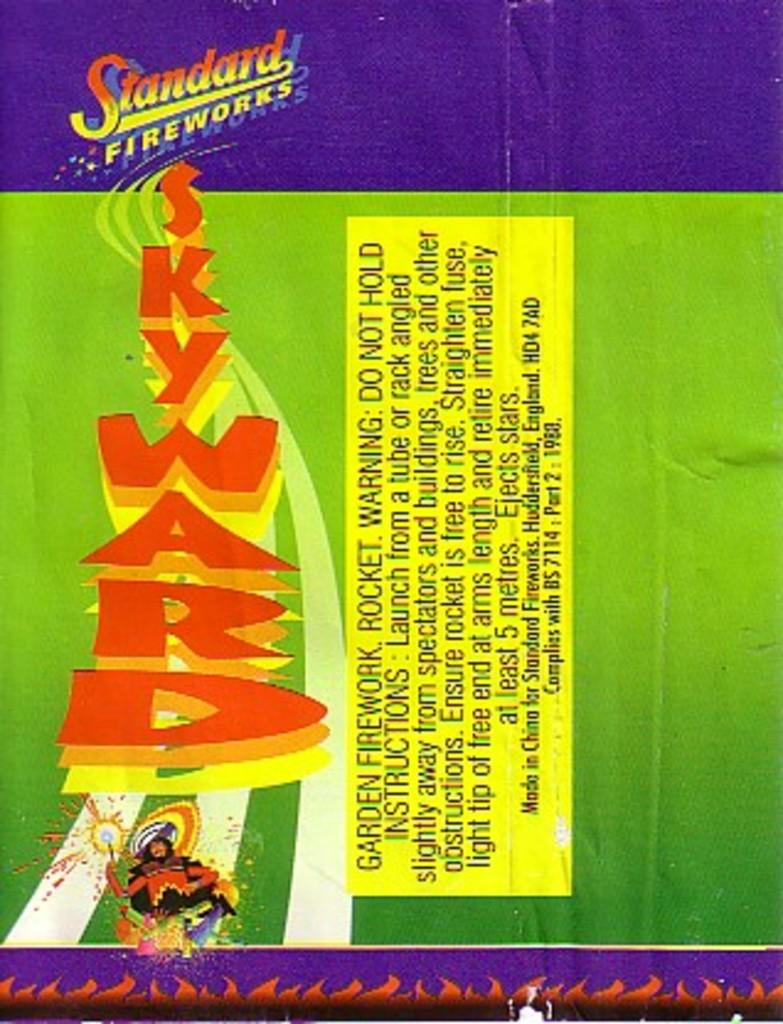Provide a one-sentence caption for the provided image. Standared fireworks from skyward that is on a fireworks box. 